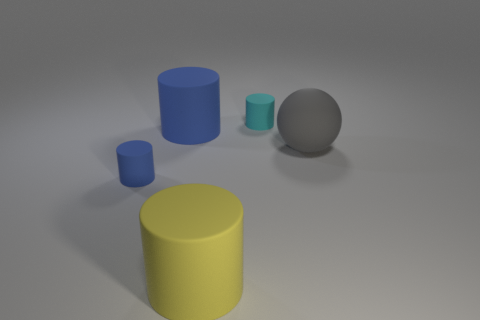Add 5 large rubber cylinders. How many objects exist? 10 Subtract all cylinders. How many objects are left? 1 Subtract 0 purple balls. How many objects are left? 5 Subtract all gray matte things. Subtract all tiny blue matte cylinders. How many objects are left? 3 Add 5 large yellow objects. How many large yellow objects are left? 6 Add 3 small gray cylinders. How many small gray cylinders exist? 3 